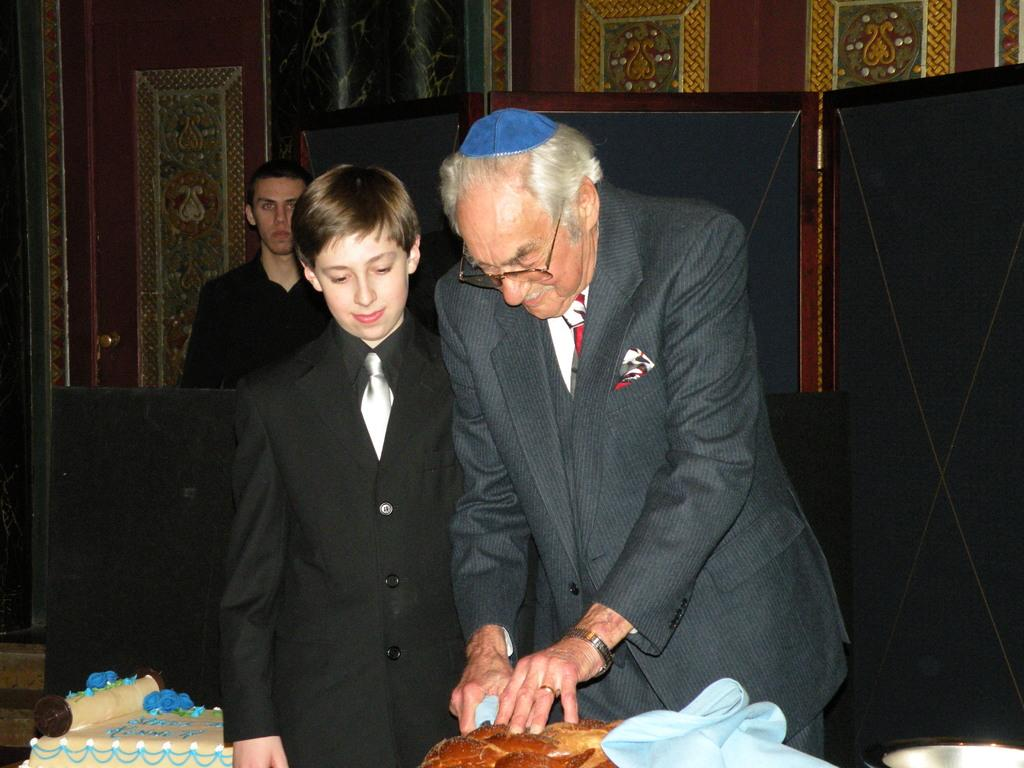What are the people in the image doing? There are persons standing at the table in the image. What is on the table? There are cakes on the table. Can you describe the background of the image? There is a person, a door, and a wall in the background. What angle does the person in the background run at to surprise the people at the table? There is no person running in the image, and the angle of approach is not mentioned or visible. 